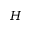<formula> <loc_0><loc_0><loc_500><loc_500>H</formula> 